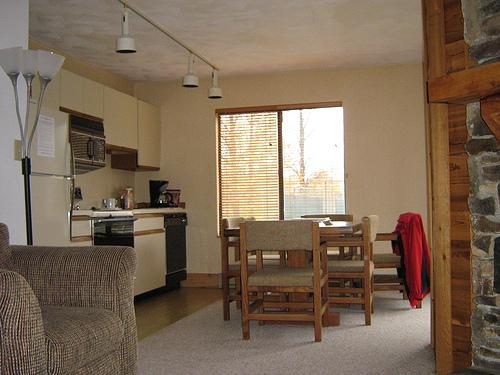Describe the light sources in the image. There is a lamp behind the chair with three heads, a tall three bulb lamp, and a row of white track lights on the ceiling. What is the overall style of the living room and any associated decor? The living room has a contemporary style with modern furniture, a combination of neutral colors like beige, grey, and black, and decorative items such as lamps, rugs, and appliances to create a cohesive and inviting space. Describe the kitchenette in the image. The kitchenette has a white refrigerator with a note attached to it, a stainless steel microwave over the stove, a black oven door, a black and metal dishwasher, and a black coffee maker on the counter. What is the general scene of the image? The scene shows an interior with a kitchenette on one wall, a soft chair with a red jacket on it, a table across the room, a window with blinds, and various furniture and decorative items across the floor and ceiling. Identify the red objects in the image and their locations. There is a red jacket hanging from the chair, a red coat on the chair, a red sweater sitting on the chair, and two red objects that are part of a stitched pattern on the couch. Describe the floor and what is on it. The floor is covered by a grey rug, and on it, there is a carpet, a cushioned wooden chair, a beige and grey sofa chair, a black coffee machine, and some other small items. Select a product from the image that you would advertise and explain why it would appeal to the customers. I would advertise the stainless steel microwave in the kitchenette. It is a compact yet modern appliance, with a sleek design that blends well with various kitchen styles, and offers convenience while heating or cooking food. Based on the given image, which object in the living room would provide a comfortable seating option? The soft chair in front of the kitchenette and the beige and grey sofa chair offer comfortable seating options in the living room. Mention the different windows present in the image and the items connected to them. There is a large window with brown blinds behind the table and two rectangular shaped windows with tree. The blinds on the window near the table are also acknowledged. How many chairs are visible in the image and where are they located? There are at least three chairs in the image - a soft chair in front of the kitchenette, a cushioned wooden chair near the table, and a set of wooden chairs around the table. 